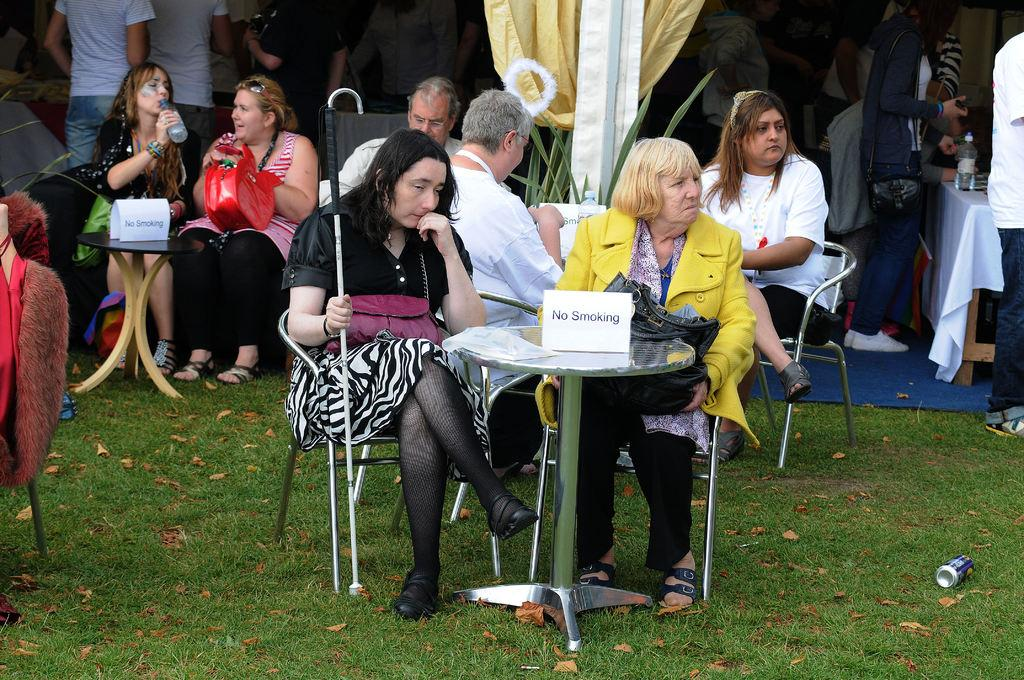Who or what can be seen in the image? There are people in the image. What are the people doing in the image? The people are sitting on chairs. Where are the chairs located in relation to the tables? The chairs are near tables. What type of surface is the ground made of? The ground is grassy. What type of apparel is the lift wearing in the image? There is no lift or apparel present in the image; it features people sitting on chairs near tables on a grassy surface. 